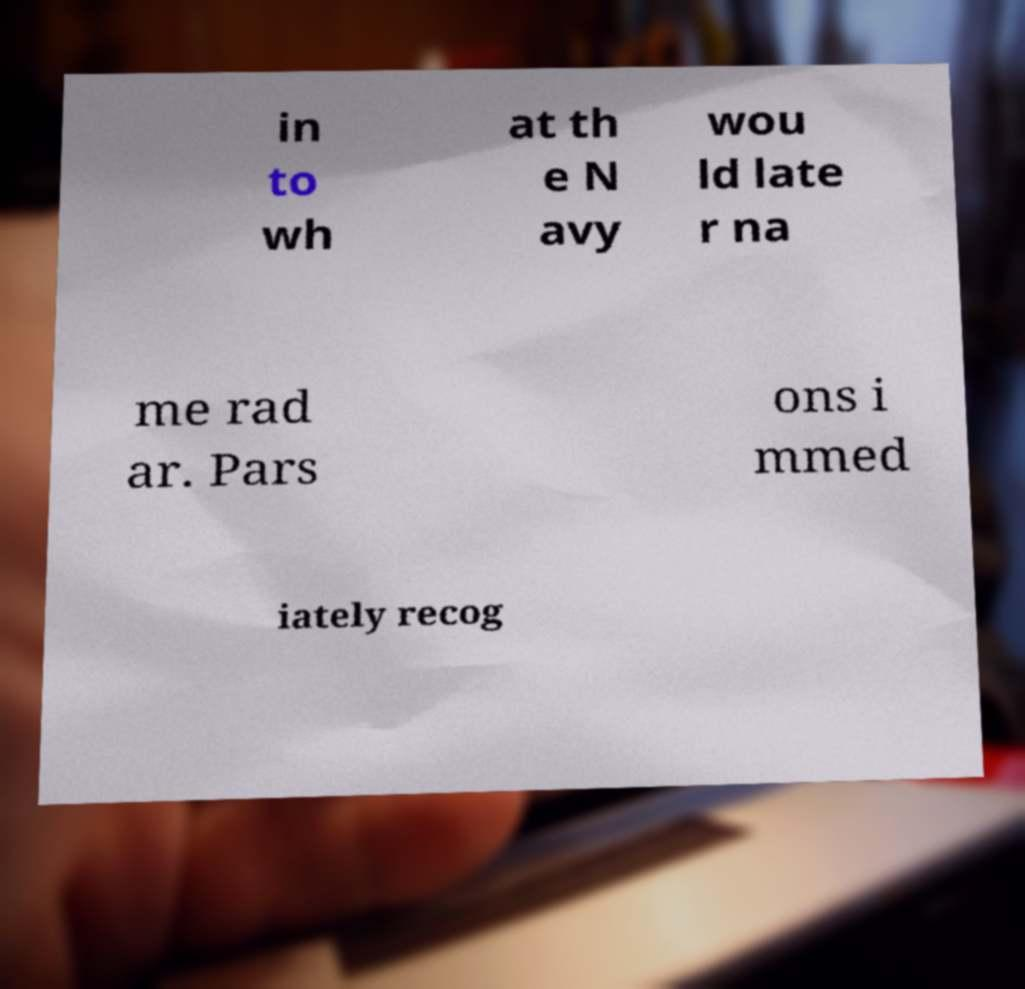I need the written content from this picture converted into text. Can you do that? in to wh at th e N avy wou ld late r na me rad ar. Pars ons i mmed iately recog 